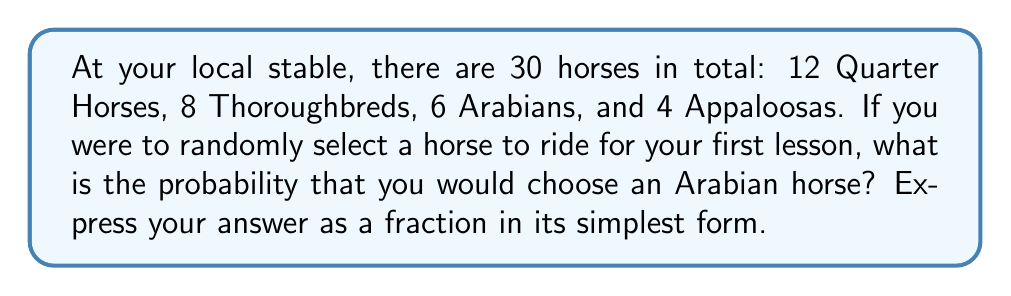Help me with this question. Let's approach this step-by-step:

1) First, we need to identify the total number of horses and the number of Arabian horses:
   - Total horses: $30$
   - Arabian horses: $6$

2) The probability of selecting an Arabian horse is the number of favorable outcomes (selecting an Arabian) divided by the total number of possible outcomes (selecting any horse):

   $$P(\text{Arabian}) = \frac{\text{Number of Arabian horses}}{\text{Total number of horses}}$$

3) Substituting our values:

   $$P(\text{Arabian}) = \frac{6}{30}$$

4) To simplify this fraction, we can divide both the numerator and denominator by their greatest common divisor (GCD). The GCD of 6 and 30 is 6:

   $$\frac{6 \div 6}{30 \div 6} = \frac{1}{5}$$

Therefore, the probability of selecting an Arabian horse is $\frac{1}{5}$.
Answer: $\frac{1}{5}$ 